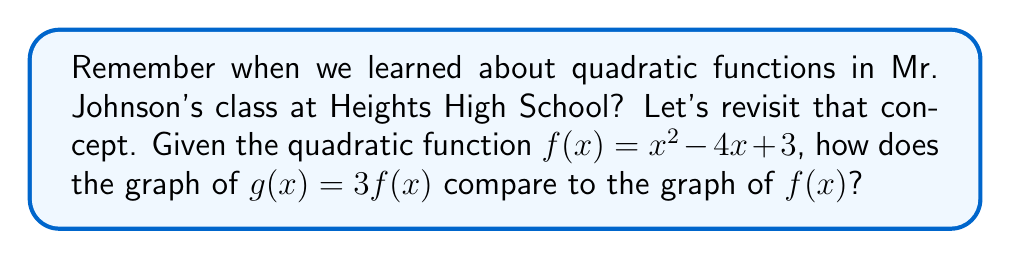Give your solution to this math problem. Let's approach this step-by-step:

1) First, recall that $f(x) = x^2 - 4x + 3$ is our original quadratic function.

2) The new function $g(x) = 3f(x)$ is a vertical stretch of $f(x)$.

3) To see how this affects the graph, let's expand $g(x)$:
   $g(x) = 3f(x) = 3(x^2 - 4x + 3)$
   $g(x) = 3x^2 - 12x + 9$

4) Compare this to the original function:
   $f(x) = x^2 - 4x + 3$
   $g(x) = 3x^2 - 12x + 9$

5) We can see that:
   - The coefficient of $x^2$ has been multiplied by 3
   - The coefficient of $x$ has been multiplied by 3
   - The constant term has been multiplied by 3

6) This means that every y-coordinate on the graph of $f(x)$ has been multiplied by 3.

7) The effect on the graph is a vertical stretch by a factor of 3. This means:
   - The parabola will appear "taller" and "thinner"
   - The vertex will remain in the same x-position, but its y-coordinate will be tripled
   - The y-intercept will be tripled
   - The distance of any point on the graph from the x-axis will be tripled
Answer: The graph of $g(x)$ is a vertical stretch of $f(x)$ by a factor of 3. 